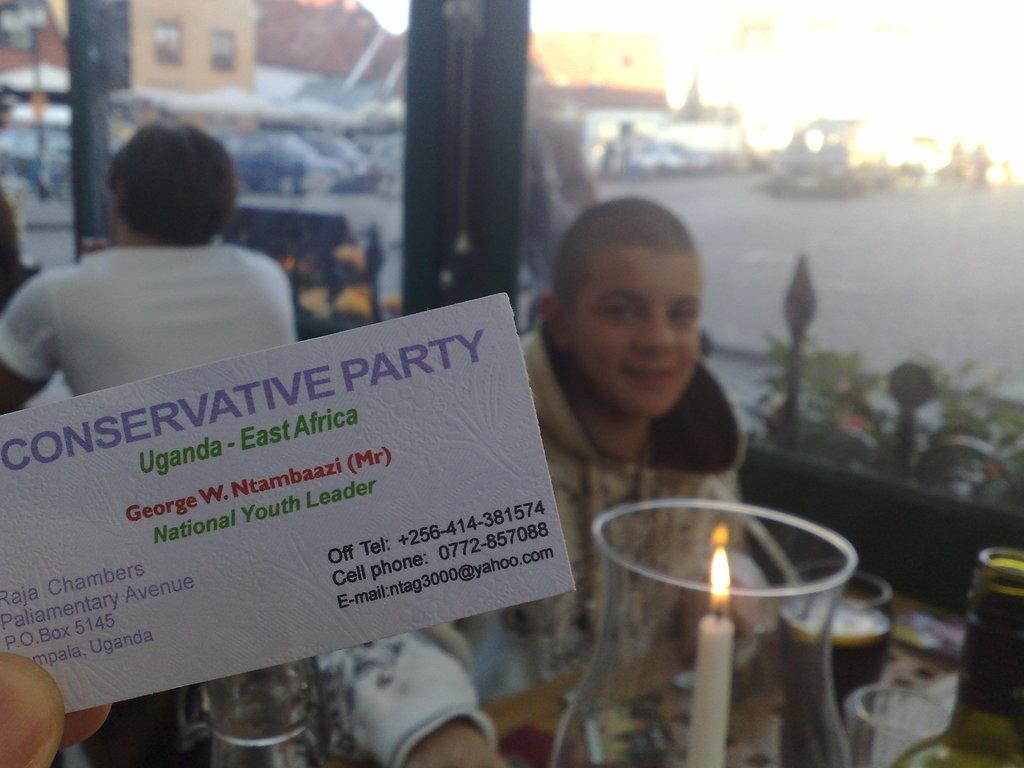What is located on the left side of the image? There is a card on the left side of the image. Can you describe the background of the image? There are people in the background of the image. What type of steel is used to create the locket in the image? There is no locket present in the image, so it is not possible to determine the type of steel used. 